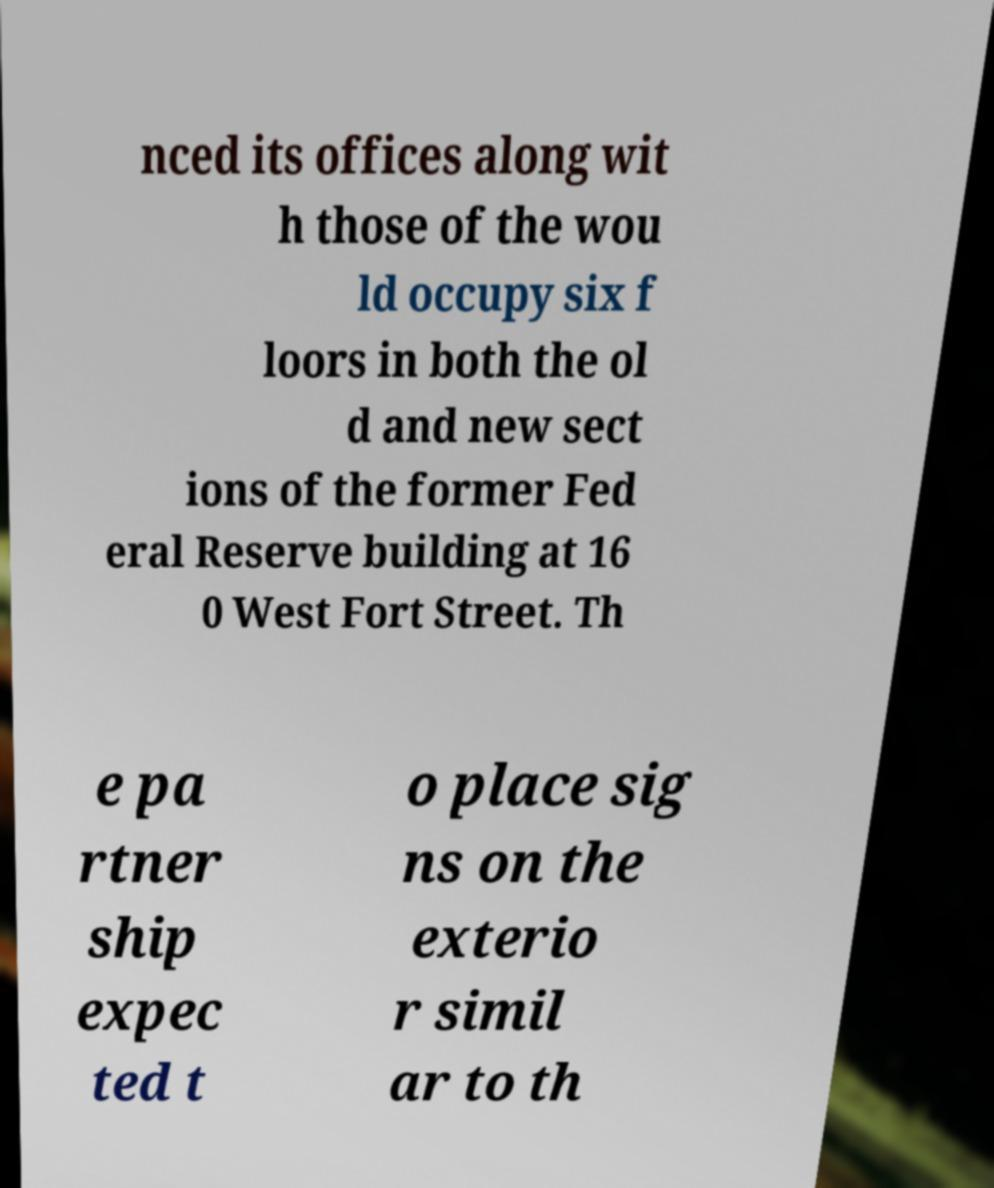I need the written content from this picture converted into text. Can you do that? nced its offices along wit h those of the wou ld occupy six f loors in both the ol d and new sect ions of the former Fed eral Reserve building at 16 0 West Fort Street. Th e pa rtner ship expec ted t o place sig ns on the exterio r simil ar to th 